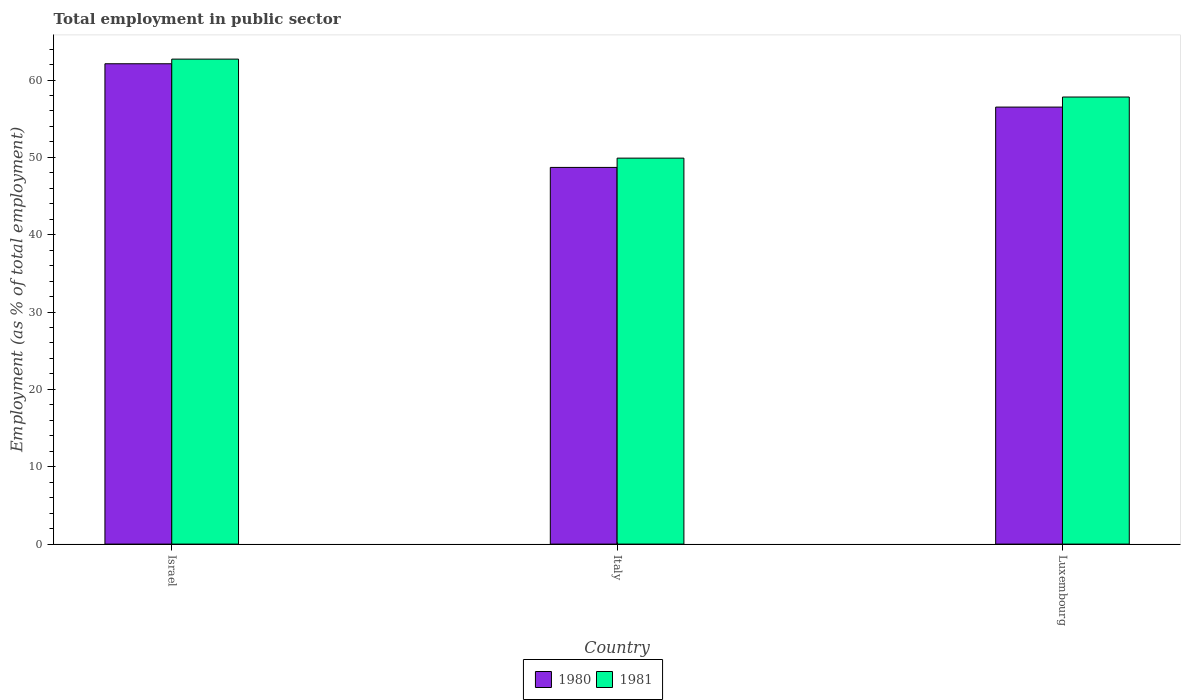Are the number of bars per tick equal to the number of legend labels?
Make the answer very short. Yes. Are the number of bars on each tick of the X-axis equal?
Offer a terse response. Yes. How many bars are there on the 3rd tick from the right?
Offer a terse response. 2. What is the employment in public sector in 1981 in Israel?
Give a very brief answer. 62.7. Across all countries, what is the maximum employment in public sector in 1981?
Your answer should be very brief. 62.7. Across all countries, what is the minimum employment in public sector in 1980?
Keep it short and to the point. 48.7. In which country was the employment in public sector in 1980 minimum?
Make the answer very short. Italy. What is the total employment in public sector in 1980 in the graph?
Make the answer very short. 167.3. What is the difference between the employment in public sector in 1981 in Italy and that in Luxembourg?
Ensure brevity in your answer.  -7.9. What is the difference between the employment in public sector in 1980 in Luxembourg and the employment in public sector in 1981 in Italy?
Give a very brief answer. 6.6. What is the average employment in public sector in 1980 per country?
Offer a terse response. 55.77. What is the difference between the employment in public sector of/in 1980 and employment in public sector of/in 1981 in Italy?
Keep it short and to the point. -1.2. In how many countries, is the employment in public sector in 1981 greater than 26 %?
Give a very brief answer. 3. What is the ratio of the employment in public sector in 1980 in Italy to that in Luxembourg?
Provide a succinct answer. 0.86. Is the difference between the employment in public sector in 1980 in Italy and Luxembourg greater than the difference between the employment in public sector in 1981 in Italy and Luxembourg?
Provide a short and direct response. Yes. What is the difference between the highest and the second highest employment in public sector in 1981?
Provide a short and direct response. -4.9. What is the difference between the highest and the lowest employment in public sector in 1981?
Your answer should be very brief. 12.8. In how many countries, is the employment in public sector in 1981 greater than the average employment in public sector in 1981 taken over all countries?
Make the answer very short. 2. What does the 1st bar from the left in Israel represents?
Make the answer very short. 1980. How many bars are there?
Ensure brevity in your answer.  6. How many countries are there in the graph?
Your answer should be very brief. 3. What is the difference between two consecutive major ticks on the Y-axis?
Provide a short and direct response. 10. Are the values on the major ticks of Y-axis written in scientific E-notation?
Your answer should be compact. No. Does the graph contain any zero values?
Your answer should be very brief. No. Where does the legend appear in the graph?
Provide a succinct answer. Bottom center. How many legend labels are there?
Your answer should be very brief. 2. How are the legend labels stacked?
Your answer should be compact. Horizontal. What is the title of the graph?
Offer a very short reply. Total employment in public sector. Does "2009" appear as one of the legend labels in the graph?
Ensure brevity in your answer.  No. What is the label or title of the X-axis?
Your answer should be compact. Country. What is the label or title of the Y-axis?
Ensure brevity in your answer.  Employment (as % of total employment). What is the Employment (as % of total employment) in 1980 in Israel?
Your response must be concise. 62.1. What is the Employment (as % of total employment) of 1981 in Israel?
Offer a very short reply. 62.7. What is the Employment (as % of total employment) in 1980 in Italy?
Provide a succinct answer. 48.7. What is the Employment (as % of total employment) of 1981 in Italy?
Provide a succinct answer. 49.9. What is the Employment (as % of total employment) in 1980 in Luxembourg?
Make the answer very short. 56.5. What is the Employment (as % of total employment) in 1981 in Luxembourg?
Offer a terse response. 57.8. Across all countries, what is the maximum Employment (as % of total employment) in 1980?
Your answer should be compact. 62.1. Across all countries, what is the maximum Employment (as % of total employment) of 1981?
Ensure brevity in your answer.  62.7. Across all countries, what is the minimum Employment (as % of total employment) of 1980?
Give a very brief answer. 48.7. Across all countries, what is the minimum Employment (as % of total employment) in 1981?
Ensure brevity in your answer.  49.9. What is the total Employment (as % of total employment) of 1980 in the graph?
Ensure brevity in your answer.  167.3. What is the total Employment (as % of total employment) in 1981 in the graph?
Your answer should be compact. 170.4. What is the difference between the Employment (as % of total employment) in 1981 in Israel and that in Italy?
Make the answer very short. 12.8. What is the difference between the Employment (as % of total employment) of 1980 in Israel and that in Luxembourg?
Give a very brief answer. 5.6. What is the difference between the Employment (as % of total employment) of 1980 in Italy and that in Luxembourg?
Provide a succinct answer. -7.8. What is the difference between the Employment (as % of total employment) of 1980 in Israel and the Employment (as % of total employment) of 1981 in Italy?
Provide a succinct answer. 12.2. What is the difference between the Employment (as % of total employment) in 1980 in Israel and the Employment (as % of total employment) in 1981 in Luxembourg?
Your answer should be very brief. 4.3. What is the average Employment (as % of total employment) in 1980 per country?
Your answer should be very brief. 55.77. What is the average Employment (as % of total employment) of 1981 per country?
Your answer should be very brief. 56.8. What is the difference between the Employment (as % of total employment) in 1980 and Employment (as % of total employment) in 1981 in Italy?
Give a very brief answer. -1.2. What is the ratio of the Employment (as % of total employment) of 1980 in Israel to that in Italy?
Ensure brevity in your answer.  1.28. What is the ratio of the Employment (as % of total employment) in 1981 in Israel to that in Italy?
Provide a short and direct response. 1.26. What is the ratio of the Employment (as % of total employment) in 1980 in Israel to that in Luxembourg?
Keep it short and to the point. 1.1. What is the ratio of the Employment (as % of total employment) in 1981 in Israel to that in Luxembourg?
Keep it short and to the point. 1.08. What is the ratio of the Employment (as % of total employment) of 1980 in Italy to that in Luxembourg?
Your answer should be very brief. 0.86. What is the ratio of the Employment (as % of total employment) in 1981 in Italy to that in Luxembourg?
Give a very brief answer. 0.86. What is the difference between the highest and the lowest Employment (as % of total employment) of 1981?
Offer a very short reply. 12.8. 